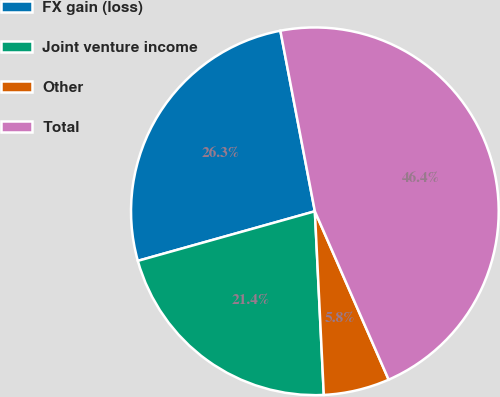<chart> <loc_0><loc_0><loc_500><loc_500><pie_chart><fcel>FX gain (loss)<fcel>Joint venture income<fcel>Other<fcel>Total<nl><fcel>26.34%<fcel>21.43%<fcel>5.8%<fcel>46.43%<nl></chart> 